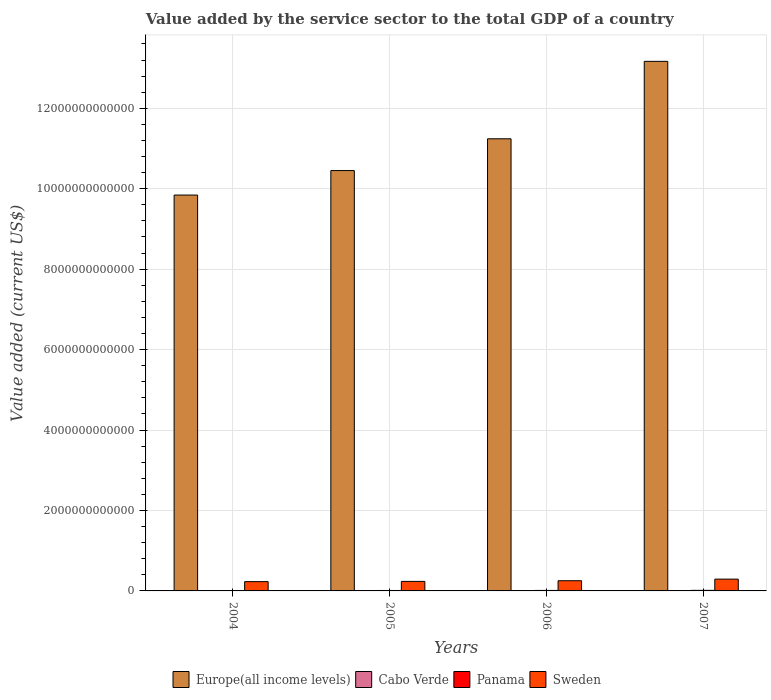Are the number of bars per tick equal to the number of legend labels?
Provide a short and direct response. Yes. What is the value added by the service sector to the total GDP in Europe(all income levels) in 2007?
Your answer should be very brief. 1.32e+13. Across all years, what is the maximum value added by the service sector to the total GDP in Cabo Verde?
Offer a terse response. 1.13e+09. Across all years, what is the minimum value added by the service sector to the total GDP in Sweden?
Offer a terse response. 2.31e+11. What is the total value added by the service sector to the total GDP in Panama in the graph?
Your answer should be very brief. 4.67e+1. What is the difference between the value added by the service sector to the total GDP in Europe(all income levels) in 2004 and that in 2006?
Your answer should be compact. -1.40e+12. What is the difference between the value added by the service sector to the total GDP in Panama in 2007 and the value added by the service sector to the total GDP in Cabo Verde in 2006?
Your response must be concise. 1.34e+1. What is the average value added by the service sector to the total GDP in Cabo Verde per year?
Ensure brevity in your answer.  8.24e+08. In the year 2006, what is the difference between the value added by the service sector to the total GDP in Panama and value added by the service sector to the total GDP in Europe(all income levels)?
Provide a short and direct response. -1.12e+13. In how many years, is the value added by the service sector to the total GDP in Panama greater than 4000000000000 US$?
Offer a terse response. 0. What is the ratio of the value added by the service sector to the total GDP in Cabo Verde in 2005 to that in 2007?
Your response must be concise. 0.62. Is the value added by the service sector to the total GDP in Cabo Verde in 2005 less than that in 2007?
Keep it short and to the point. Yes. Is the difference between the value added by the service sector to the total GDP in Panama in 2004 and 2005 greater than the difference between the value added by the service sector to the total GDP in Europe(all income levels) in 2004 and 2005?
Give a very brief answer. Yes. What is the difference between the highest and the second highest value added by the service sector to the total GDP in Sweden?
Make the answer very short. 3.95e+1. What is the difference between the highest and the lowest value added by the service sector to the total GDP in Panama?
Make the answer very short. 5.11e+09. What does the 1st bar from the left in 2006 represents?
Offer a very short reply. Europe(all income levels). What does the 3rd bar from the right in 2006 represents?
Offer a terse response. Cabo Verde. Is it the case that in every year, the sum of the value added by the service sector to the total GDP in Panama and value added by the service sector to the total GDP in Cabo Verde is greater than the value added by the service sector to the total GDP in Europe(all income levels)?
Your answer should be compact. No. Are all the bars in the graph horizontal?
Offer a terse response. No. How many years are there in the graph?
Provide a short and direct response. 4. What is the difference between two consecutive major ticks on the Y-axis?
Provide a succinct answer. 2.00e+12. Are the values on the major ticks of Y-axis written in scientific E-notation?
Provide a short and direct response. No. Does the graph contain grids?
Give a very brief answer. Yes. Where does the legend appear in the graph?
Offer a terse response. Bottom center. How are the legend labels stacked?
Give a very brief answer. Horizontal. What is the title of the graph?
Give a very brief answer. Value added by the service sector to the total GDP of a country. What is the label or title of the X-axis?
Offer a very short reply. Years. What is the label or title of the Y-axis?
Ensure brevity in your answer.  Value added (current US$). What is the Value added (current US$) of Europe(all income levels) in 2004?
Make the answer very short. 9.84e+12. What is the Value added (current US$) of Cabo Verde in 2004?
Your answer should be very brief. 6.65e+08. What is the Value added (current US$) in Panama in 2004?
Make the answer very short. 9.07e+09. What is the Value added (current US$) in Sweden in 2004?
Offer a terse response. 2.31e+11. What is the Value added (current US$) of Europe(all income levels) in 2005?
Offer a terse response. 1.05e+13. What is the Value added (current US$) of Cabo Verde in 2005?
Your response must be concise. 6.98e+08. What is the Value added (current US$) in Panama in 2005?
Offer a terse response. 1.10e+1. What is the Value added (current US$) in Sweden in 2005?
Offer a terse response. 2.37e+11. What is the Value added (current US$) in Europe(all income levels) in 2006?
Your answer should be compact. 1.12e+13. What is the Value added (current US$) in Cabo Verde in 2006?
Provide a succinct answer. 8.04e+08. What is the Value added (current US$) of Panama in 2006?
Give a very brief answer. 1.24e+1. What is the Value added (current US$) in Sweden in 2006?
Keep it short and to the point. 2.53e+11. What is the Value added (current US$) of Europe(all income levels) in 2007?
Keep it short and to the point. 1.32e+13. What is the Value added (current US$) in Cabo Verde in 2007?
Ensure brevity in your answer.  1.13e+09. What is the Value added (current US$) in Panama in 2007?
Your answer should be very brief. 1.42e+1. What is the Value added (current US$) of Sweden in 2007?
Your answer should be very brief. 2.93e+11. Across all years, what is the maximum Value added (current US$) in Europe(all income levels)?
Your response must be concise. 1.32e+13. Across all years, what is the maximum Value added (current US$) in Cabo Verde?
Offer a terse response. 1.13e+09. Across all years, what is the maximum Value added (current US$) of Panama?
Offer a very short reply. 1.42e+1. Across all years, what is the maximum Value added (current US$) of Sweden?
Keep it short and to the point. 2.93e+11. Across all years, what is the minimum Value added (current US$) of Europe(all income levels)?
Ensure brevity in your answer.  9.84e+12. Across all years, what is the minimum Value added (current US$) in Cabo Verde?
Keep it short and to the point. 6.65e+08. Across all years, what is the minimum Value added (current US$) in Panama?
Your answer should be very brief. 9.07e+09. Across all years, what is the minimum Value added (current US$) of Sweden?
Provide a succinct answer. 2.31e+11. What is the total Value added (current US$) in Europe(all income levels) in the graph?
Make the answer very short. 4.47e+13. What is the total Value added (current US$) of Cabo Verde in the graph?
Offer a terse response. 3.30e+09. What is the total Value added (current US$) of Panama in the graph?
Make the answer very short. 4.67e+1. What is the total Value added (current US$) of Sweden in the graph?
Keep it short and to the point. 1.01e+12. What is the difference between the Value added (current US$) of Europe(all income levels) in 2004 and that in 2005?
Offer a very short reply. -6.09e+11. What is the difference between the Value added (current US$) in Cabo Verde in 2004 and that in 2005?
Your answer should be very brief. -3.30e+07. What is the difference between the Value added (current US$) of Panama in 2004 and that in 2005?
Give a very brief answer. -1.95e+09. What is the difference between the Value added (current US$) in Sweden in 2004 and that in 2005?
Give a very brief answer. -5.87e+09. What is the difference between the Value added (current US$) in Europe(all income levels) in 2004 and that in 2006?
Keep it short and to the point. -1.40e+12. What is the difference between the Value added (current US$) of Cabo Verde in 2004 and that in 2006?
Your answer should be compact. -1.39e+08. What is the difference between the Value added (current US$) in Panama in 2004 and that in 2006?
Offer a terse response. -3.29e+09. What is the difference between the Value added (current US$) in Sweden in 2004 and that in 2006?
Give a very brief answer. -2.26e+1. What is the difference between the Value added (current US$) of Europe(all income levels) in 2004 and that in 2007?
Provide a succinct answer. -3.32e+12. What is the difference between the Value added (current US$) in Cabo Verde in 2004 and that in 2007?
Provide a succinct answer. -4.64e+08. What is the difference between the Value added (current US$) in Panama in 2004 and that in 2007?
Provide a short and direct response. -5.11e+09. What is the difference between the Value added (current US$) of Sweden in 2004 and that in 2007?
Provide a succinct answer. -6.20e+1. What is the difference between the Value added (current US$) in Europe(all income levels) in 2005 and that in 2006?
Ensure brevity in your answer.  -7.90e+11. What is the difference between the Value added (current US$) in Cabo Verde in 2005 and that in 2006?
Your answer should be very brief. -1.06e+08. What is the difference between the Value added (current US$) in Panama in 2005 and that in 2006?
Ensure brevity in your answer.  -1.34e+09. What is the difference between the Value added (current US$) of Sweden in 2005 and that in 2006?
Your response must be concise. -1.67e+1. What is the difference between the Value added (current US$) in Europe(all income levels) in 2005 and that in 2007?
Provide a short and direct response. -2.72e+12. What is the difference between the Value added (current US$) of Cabo Verde in 2005 and that in 2007?
Make the answer very short. -4.31e+08. What is the difference between the Value added (current US$) of Panama in 2005 and that in 2007?
Provide a succinct answer. -3.16e+09. What is the difference between the Value added (current US$) of Sweden in 2005 and that in 2007?
Make the answer very short. -5.62e+1. What is the difference between the Value added (current US$) of Europe(all income levels) in 2006 and that in 2007?
Ensure brevity in your answer.  -1.93e+12. What is the difference between the Value added (current US$) in Cabo Verde in 2006 and that in 2007?
Give a very brief answer. -3.25e+08. What is the difference between the Value added (current US$) of Panama in 2006 and that in 2007?
Make the answer very short. -1.82e+09. What is the difference between the Value added (current US$) of Sweden in 2006 and that in 2007?
Give a very brief answer. -3.95e+1. What is the difference between the Value added (current US$) in Europe(all income levels) in 2004 and the Value added (current US$) in Cabo Verde in 2005?
Your answer should be very brief. 9.84e+12. What is the difference between the Value added (current US$) in Europe(all income levels) in 2004 and the Value added (current US$) in Panama in 2005?
Offer a very short reply. 9.83e+12. What is the difference between the Value added (current US$) in Europe(all income levels) in 2004 and the Value added (current US$) in Sweden in 2005?
Make the answer very short. 9.61e+12. What is the difference between the Value added (current US$) of Cabo Verde in 2004 and the Value added (current US$) of Panama in 2005?
Give a very brief answer. -1.04e+1. What is the difference between the Value added (current US$) in Cabo Verde in 2004 and the Value added (current US$) in Sweden in 2005?
Offer a very short reply. -2.36e+11. What is the difference between the Value added (current US$) in Panama in 2004 and the Value added (current US$) in Sweden in 2005?
Ensure brevity in your answer.  -2.28e+11. What is the difference between the Value added (current US$) of Europe(all income levels) in 2004 and the Value added (current US$) of Cabo Verde in 2006?
Offer a terse response. 9.84e+12. What is the difference between the Value added (current US$) in Europe(all income levels) in 2004 and the Value added (current US$) in Panama in 2006?
Your response must be concise. 9.83e+12. What is the difference between the Value added (current US$) in Europe(all income levels) in 2004 and the Value added (current US$) in Sweden in 2006?
Your answer should be very brief. 9.59e+12. What is the difference between the Value added (current US$) in Cabo Verde in 2004 and the Value added (current US$) in Panama in 2006?
Ensure brevity in your answer.  -1.17e+1. What is the difference between the Value added (current US$) of Cabo Verde in 2004 and the Value added (current US$) of Sweden in 2006?
Offer a very short reply. -2.53e+11. What is the difference between the Value added (current US$) of Panama in 2004 and the Value added (current US$) of Sweden in 2006?
Your answer should be very brief. -2.44e+11. What is the difference between the Value added (current US$) in Europe(all income levels) in 2004 and the Value added (current US$) in Cabo Verde in 2007?
Ensure brevity in your answer.  9.84e+12. What is the difference between the Value added (current US$) of Europe(all income levels) in 2004 and the Value added (current US$) of Panama in 2007?
Ensure brevity in your answer.  9.83e+12. What is the difference between the Value added (current US$) of Europe(all income levels) in 2004 and the Value added (current US$) of Sweden in 2007?
Offer a very short reply. 9.55e+12. What is the difference between the Value added (current US$) of Cabo Verde in 2004 and the Value added (current US$) of Panama in 2007?
Offer a very short reply. -1.35e+1. What is the difference between the Value added (current US$) of Cabo Verde in 2004 and the Value added (current US$) of Sweden in 2007?
Your response must be concise. -2.92e+11. What is the difference between the Value added (current US$) in Panama in 2004 and the Value added (current US$) in Sweden in 2007?
Keep it short and to the point. -2.84e+11. What is the difference between the Value added (current US$) of Europe(all income levels) in 2005 and the Value added (current US$) of Cabo Verde in 2006?
Provide a succinct answer. 1.05e+13. What is the difference between the Value added (current US$) in Europe(all income levels) in 2005 and the Value added (current US$) in Panama in 2006?
Make the answer very short. 1.04e+13. What is the difference between the Value added (current US$) of Europe(all income levels) in 2005 and the Value added (current US$) of Sweden in 2006?
Offer a very short reply. 1.02e+13. What is the difference between the Value added (current US$) of Cabo Verde in 2005 and the Value added (current US$) of Panama in 2006?
Ensure brevity in your answer.  -1.17e+1. What is the difference between the Value added (current US$) in Cabo Verde in 2005 and the Value added (current US$) in Sweden in 2006?
Provide a succinct answer. -2.53e+11. What is the difference between the Value added (current US$) of Panama in 2005 and the Value added (current US$) of Sweden in 2006?
Provide a short and direct response. -2.42e+11. What is the difference between the Value added (current US$) in Europe(all income levels) in 2005 and the Value added (current US$) in Cabo Verde in 2007?
Make the answer very short. 1.05e+13. What is the difference between the Value added (current US$) in Europe(all income levels) in 2005 and the Value added (current US$) in Panama in 2007?
Your response must be concise. 1.04e+13. What is the difference between the Value added (current US$) of Europe(all income levels) in 2005 and the Value added (current US$) of Sweden in 2007?
Offer a terse response. 1.02e+13. What is the difference between the Value added (current US$) in Cabo Verde in 2005 and the Value added (current US$) in Panama in 2007?
Your answer should be very brief. -1.35e+1. What is the difference between the Value added (current US$) in Cabo Verde in 2005 and the Value added (current US$) in Sweden in 2007?
Your answer should be compact. -2.92e+11. What is the difference between the Value added (current US$) of Panama in 2005 and the Value added (current US$) of Sweden in 2007?
Offer a terse response. -2.82e+11. What is the difference between the Value added (current US$) of Europe(all income levels) in 2006 and the Value added (current US$) of Cabo Verde in 2007?
Offer a terse response. 1.12e+13. What is the difference between the Value added (current US$) of Europe(all income levels) in 2006 and the Value added (current US$) of Panama in 2007?
Provide a short and direct response. 1.12e+13. What is the difference between the Value added (current US$) of Europe(all income levels) in 2006 and the Value added (current US$) of Sweden in 2007?
Your answer should be very brief. 1.09e+13. What is the difference between the Value added (current US$) of Cabo Verde in 2006 and the Value added (current US$) of Panama in 2007?
Make the answer very short. -1.34e+1. What is the difference between the Value added (current US$) in Cabo Verde in 2006 and the Value added (current US$) in Sweden in 2007?
Make the answer very short. -2.92e+11. What is the difference between the Value added (current US$) of Panama in 2006 and the Value added (current US$) of Sweden in 2007?
Make the answer very short. -2.81e+11. What is the average Value added (current US$) in Europe(all income levels) per year?
Ensure brevity in your answer.  1.12e+13. What is the average Value added (current US$) of Cabo Verde per year?
Offer a terse response. 8.24e+08. What is the average Value added (current US$) of Panama per year?
Your answer should be very brief. 1.17e+1. What is the average Value added (current US$) in Sweden per year?
Provide a succinct answer. 2.54e+11. In the year 2004, what is the difference between the Value added (current US$) of Europe(all income levels) and Value added (current US$) of Cabo Verde?
Keep it short and to the point. 9.84e+12. In the year 2004, what is the difference between the Value added (current US$) in Europe(all income levels) and Value added (current US$) in Panama?
Give a very brief answer. 9.83e+12. In the year 2004, what is the difference between the Value added (current US$) of Europe(all income levels) and Value added (current US$) of Sweden?
Keep it short and to the point. 9.61e+12. In the year 2004, what is the difference between the Value added (current US$) in Cabo Verde and Value added (current US$) in Panama?
Give a very brief answer. -8.41e+09. In the year 2004, what is the difference between the Value added (current US$) of Cabo Verde and Value added (current US$) of Sweden?
Offer a terse response. -2.30e+11. In the year 2004, what is the difference between the Value added (current US$) in Panama and Value added (current US$) in Sweden?
Make the answer very short. -2.22e+11. In the year 2005, what is the difference between the Value added (current US$) in Europe(all income levels) and Value added (current US$) in Cabo Verde?
Your response must be concise. 1.05e+13. In the year 2005, what is the difference between the Value added (current US$) in Europe(all income levels) and Value added (current US$) in Panama?
Offer a terse response. 1.04e+13. In the year 2005, what is the difference between the Value added (current US$) in Europe(all income levels) and Value added (current US$) in Sweden?
Ensure brevity in your answer.  1.02e+13. In the year 2005, what is the difference between the Value added (current US$) of Cabo Verde and Value added (current US$) of Panama?
Keep it short and to the point. -1.03e+1. In the year 2005, what is the difference between the Value added (current US$) in Cabo Verde and Value added (current US$) in Sweden?
Make the answer very short. -2.36e+11. In the year 2005, what is the difference between the Value added (current US$) of Panama and Value added (current US$) of Sweden?
Give a very brief answer. -2.26e+11. In the year 2006, what is the difference between the Value added (current US$) of Europe(all income levels) and Value added (current US$) of Cabo Verde?
Provide a short and direct response. 1.12e+13. In the year 2006, what is the difference between the Value added (current US$) in Europe(all income levels) and Value added (current US$) in Panama?
Your answer should be compact. 1.12e+13. In the year 2006, what is the difference between the Value added (current US$) in Europe(all income levels) and Value added (current US$) in Sweden?
Provide a short and direct response. 1.10e+13. In the year 2006, what is the difference between the Value added (current US$) of Cabo Verde and Value added (current US$) of Panama?
Keep it short and to the point. -1.16e+1. In the year 2006, what is the difference between the Value added (current US$) in Cabo Verde and Value added (current US$) in Sweden?
Make the answer very short. -2.53e+11. In the year 2006, what is the difference between the Value added (current US$) of Panama and Value added (current US$) of Sweden?
Provide a short and direct response. -2.41e+11. In the year 2007, what is the difference between the Value added (current US$) of Europe(all income levels) and Value added (current US$) of Cabo Verde?
Make the answer very short. 1.32e+13. In the year 2007, what is the difference between the Value added (current US$) in Europe(all income levels) and Value added (current US$) in Panama?
Ensure brevity in your answer.  1.32e+13. In the year 2007, what is the difference between the Value added (current US$) in Europe(all income levels) and Value added (current US$) in Sweden?
Your response must be concise. 1.29e+13. In the year 2007, what is the difference between the Value added (current US$) of Cabo Verde and Value added (current US$) of Panama?
Your response must be concise. -1.31e+1. In the year 2007, what is the difference between the Value added (current US$) in Cabo Verde and Value added (current US$) in Sweden?
Offer a very short reply. -2.92e+11. In the year 2007, what is the difference between the Value added (current US$) of Panama and Value added (current US$) of Sweden?
Your answer should be very brief. -2.79e+11. What is the ratio of the Value added (current US$) of Europe(all income levels) in 2004 to that in 2005?
Your answer should be very brief. 0.94. What is the ratio of the Value added (current US$) of Cabo Verde in 2004 to that in 2005?
Your response must be concise. 0.95. What is the ratio of the Value added (current US$) in Panama in 2004 to that in 2005?
Give a very brief answer. 0.82. What is the ratio of the Value added (current US$) in Sweden in 2004 to that in 2005?
Offer a very short reply. 0.98. What is the ratio of the Value added (current US$) in Europe(all income levels) in 2004 to that in 2006?
Ensure brevity in your answer.  0.88. What is the ratio of the Value added (current US$) of Cabo Verde in 2004 to that in 2006?
Keep it short and to the point. 0.83. What is the ratio of the Value added (current US$) in Panama in 2004 to that in 2006?
Offer a terse response. 0.73. What is the ratio of the Value added (current US$) of Sweden in 2004 to that in 2006?
Make the answer very short. 0.91. What is the ratio of the Value added (current US$) in Europe(all income levels) in 2004 to that in 2007?
Your answer should be very brief. 0.75. What is the ratio of the Value added (current US$) in Cabo Verde in 2004 to that in 2007?
Make the answer very short. 0.59. What is the ratio of the Value added (current US$) of Panama in 2004 to that in 2007?
Offer a very short reply. 0.64. What is the ratio of the Value added (current US$) in Sweden in 2004 to that in 2007?
Your answer should be very brief. 0.79. What is the ratio of the Value added (current US$) of Europe(all income levels) in 2005 to that in 2006?
Give a very brief answer. 0.93. What is the ratio of the Value added (current US$) in Cabo Verde in 2005 to that in 2006?
Offer a terse response. 0.87. What is the ratio of the Value added (current US$) of Panama in 2005 to that in 2006?
Give a very brief answer. 0.89. What is the ratio of the Value added (current US$) of Sweden in 2005 to that in 2006?
Keep it short and to the point. 0.93. What is the ratio of the Value added (current US$) in Europe(all income levels) in 2005 to that in 2007?
Provide a succinct answer. 0.79. What is the ratio of the Value added (current US$) of Cabo Verde in 2005 to that in 2007?
Provide a succinct answer. 0.62. What is the ratio of the Value added (current US$) in Panama in 2005 to that in 2007?
Your response must be concise. 0.78. What is the ratio of the Value added (current US$) of Sweden in 2005 to that in 2007?
Provide a succinct answer. 0.81. What is the ratio of the Value added (current US$) in Europe(all income levels) in 2006 to that in 2007?
Keep it short and to the point. 0.85. What is the ratio of the Value added (current US$) of Cabo Verde in 2006 to that in 2007?
Provide a succinct answer. 0.71. What is the ratio of the Value added (current US$) in Panama in 2006 to that in 2007?
Give a very brief answer. 0.87. What is the ratio of the Value added (current US$) of Sweden in 2006 to that in 2007?
Your answer should be compact. 0.87. What is the difference between the highest and the second highest Value added (current US$) in Europe(all income levels)?
Make the answer very short. 1.93e+12. What is the difference between the highest and the second highest Value added (current US$) of Cabo Verde?
Ensure brevity in your answer.  3.25e+08. What is the difference between the highest and the second highest Value added (current US$) in Panama?
Offer a terse response. 1.82e+09. What is the difference between the highest and the second highest Value added (current US$) of Sweden?
Ensure brevity in your answer.  3.95e+1. What is the difference between the highest and the lowest Value added (current US$) in Europe(all income levels)?
Your answer should be very brief. 3.32e+12. What is the difference between the highest and the lowest Value added (current US$) in Cabo Verde?
Make the answer very short. 4.64e+08. What is the difference between the highest and the lowest Value added (current US$) of Panama?
Ensure brevity in your answer.  5.11e+09. What is the difference between the highest and the lowest Value added (current US$) in Sweden?
Your response must be concise. 6.20e+1. 